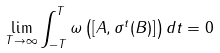Convert formula to latex. <formula><loc_0><loc_0><loc_500><loc_500>\underset { T \rightarrow \infty } { \lim } \int ^ { T } _ { - T } \omega \left ( [ A , \sigma ^ { t } ( B ) ] \right ) d t = 0</formula> 